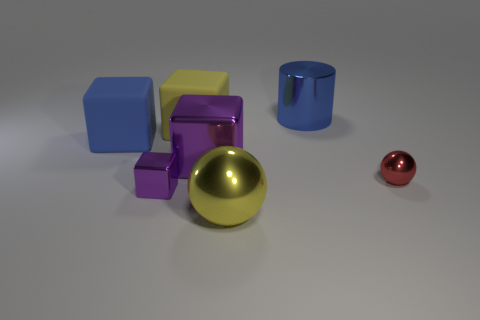Subtract all gray cylinders. How many purple cubes are left? 2 Subtract all yellow matte blocks. How many blocks are left? 3 Subtract 2 cubes. How many cubes are left? 2 Subtract all blue cubes. How many cubes are left? 3 Add 3 big blue objects. How many objects exist? 10 Subtract all cubes. How many objects are left? 3 Subtract all brown cubes. Subtract all gray spheres. How many cubes are left? 4 Add 2 large gray rubber blocks. How many large gray rubber blocks exist? 2 Subtract 0 green cylinders. How many objects are left? 7 Subtract all green shiny cylinders. Subtract all small red things. How many objects are left? 6 